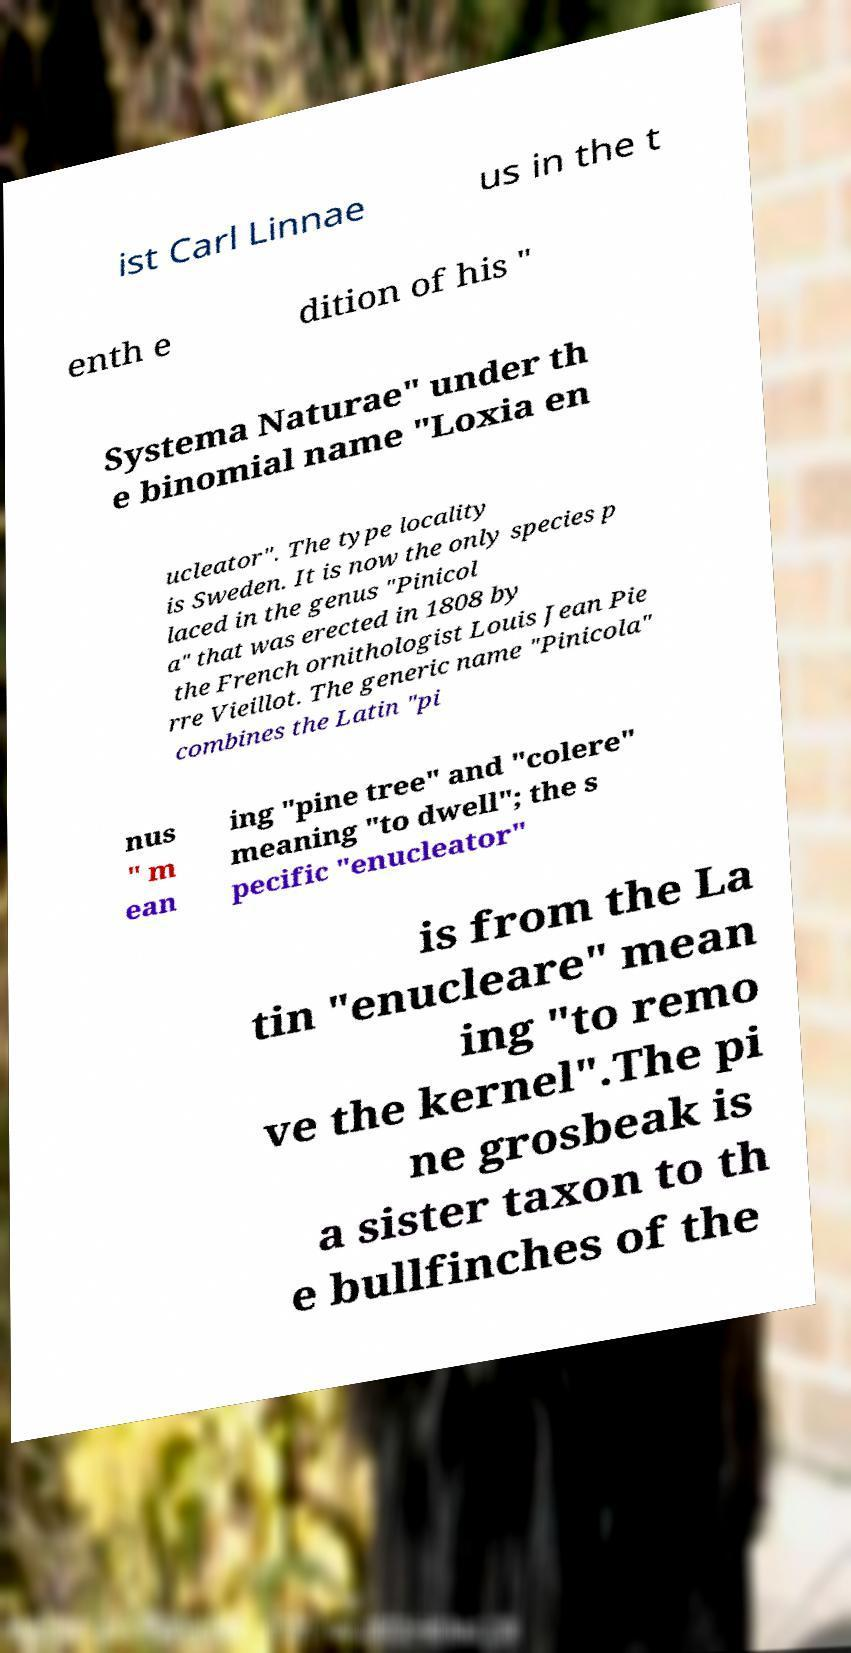For documentation purposes, I need the text within this image transcribed. Could you provide that? ist Carl Linnae us in the t enth e dition of his " Systema Naturae" under th e binomial name "Loxia en ucleator". The type locality is Sweden. It is now the only species p laced in the genus "Pinicol a" that was erected in 1808 by the French ornithologist Louis Jean Pie rre Vieillot. The generic name "Pinicola" combines the Latin "pi nus " m ean ing "pine tree" and "colere" meaning "to dwell"; the s pecific "enucleator" is from the La tin "enucleare" mean ing "to remo ve the kernel".The pi ne grosbeak is a sister taxon to th e bullfinches of the 